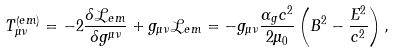Convert formula to latex. <formula><loc_0><loc_0><loc_500><loc_500>T _ { \mu \nu } ^ { \left ( e m \right ) } = - 2 \frac { \delta \mathcal { L } _ { e m } } { \delta g ^ { \mu \nu } } + g _ { \mu \nu } \mathcal { L } _ { e m } = - g _ { \mu \nu } \frac { \alpha _ { g } c ^ { 2 } } { 2 \mu _ { 0 } } \left ( B ^ { 2 } - \frac { E ^ { 2 } } { c ^ { 2 } } \right ) ,</formula> 